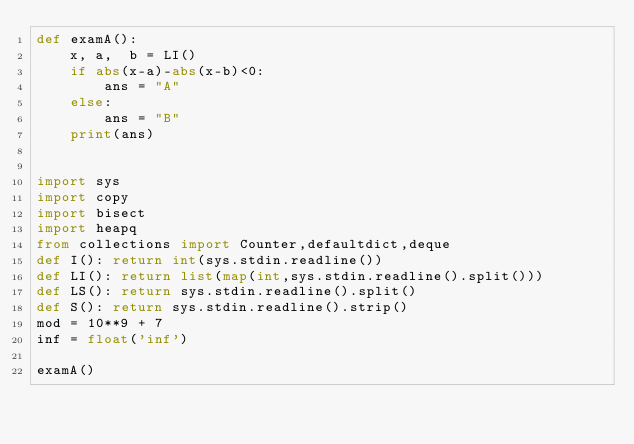<code> <loc_0><loc_0><loc_500><loc_500><_Python_>def examA():
    x, a,  b = LI()
    if abs(x-a)-abs(x-b)<0:
        ans = "A"
    else:
        ans = "B"
    print(ans)


import sys
import copy
import bisect
import heapq
from collections import Counter,defaultdict,deque
def I(): return int(sys.stdin.readline())
def LI(): return list(map(int,sys.stdin.readline().split()))
def LS(): return sys.stdin.readline().split()
def S(): return sys.stdin.readline().strip()
mod = 10**9 + 7
inf = float('inf')

examA()
</code> 